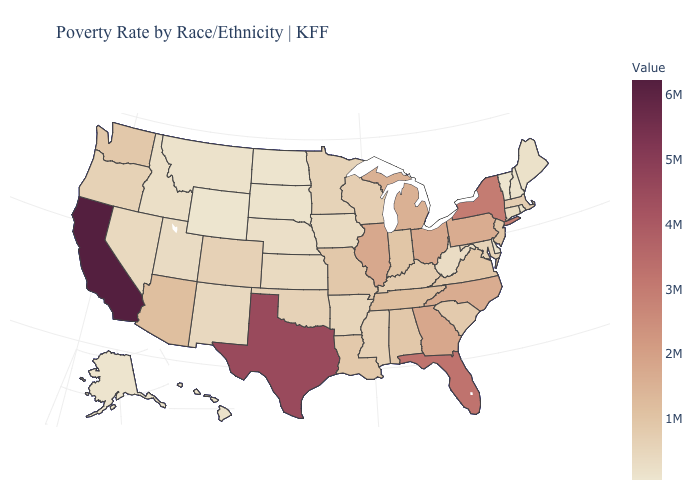Does California have the highest value in the USA?
Quick response, please. Yes. Among the states that border South Carolina , does North Carolina have the highest value?
Keep it brief. No. Among the states that border New Mexico , does Utah have the lowest value?
Write a very short answer. Yes. 